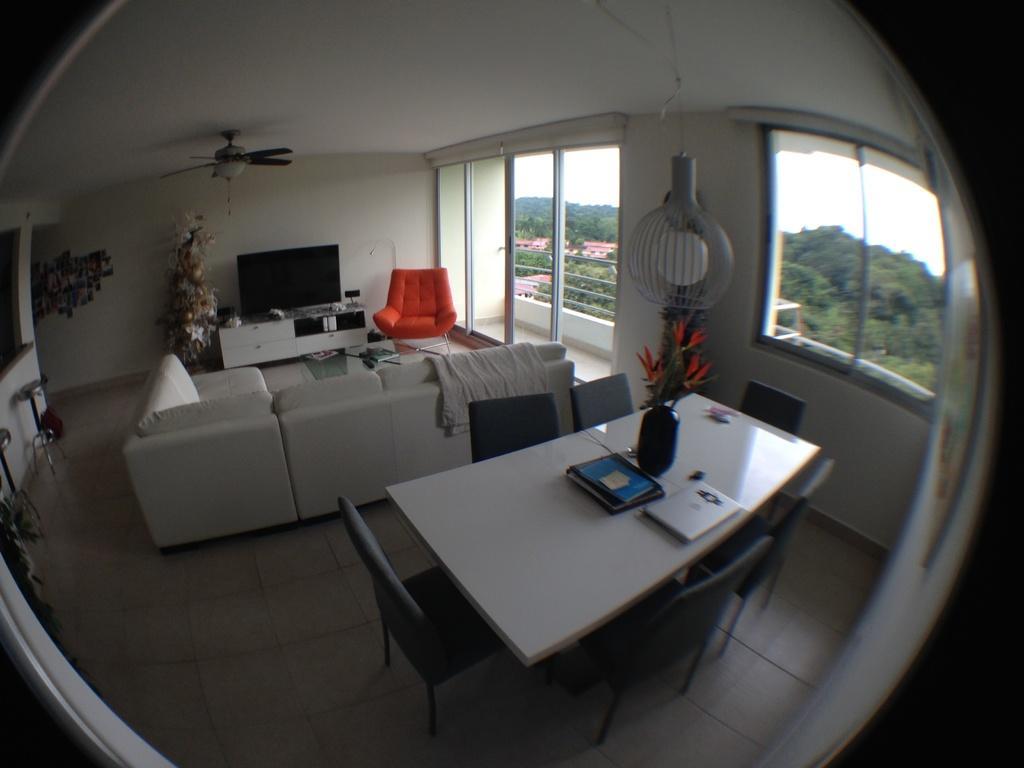Please provide a concise description of this image. In this image, I can see a table on which books, flower vase are there, chairs on the floor, sofas, houseplants and a TV table. In the background, I can see windows, chandeliers and a wall and I can see trees and the sky. This image taken, maybe in a room. 